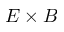<formula> <loc_0><loc_0><loc_500><loc_500>E \times B</formula> 